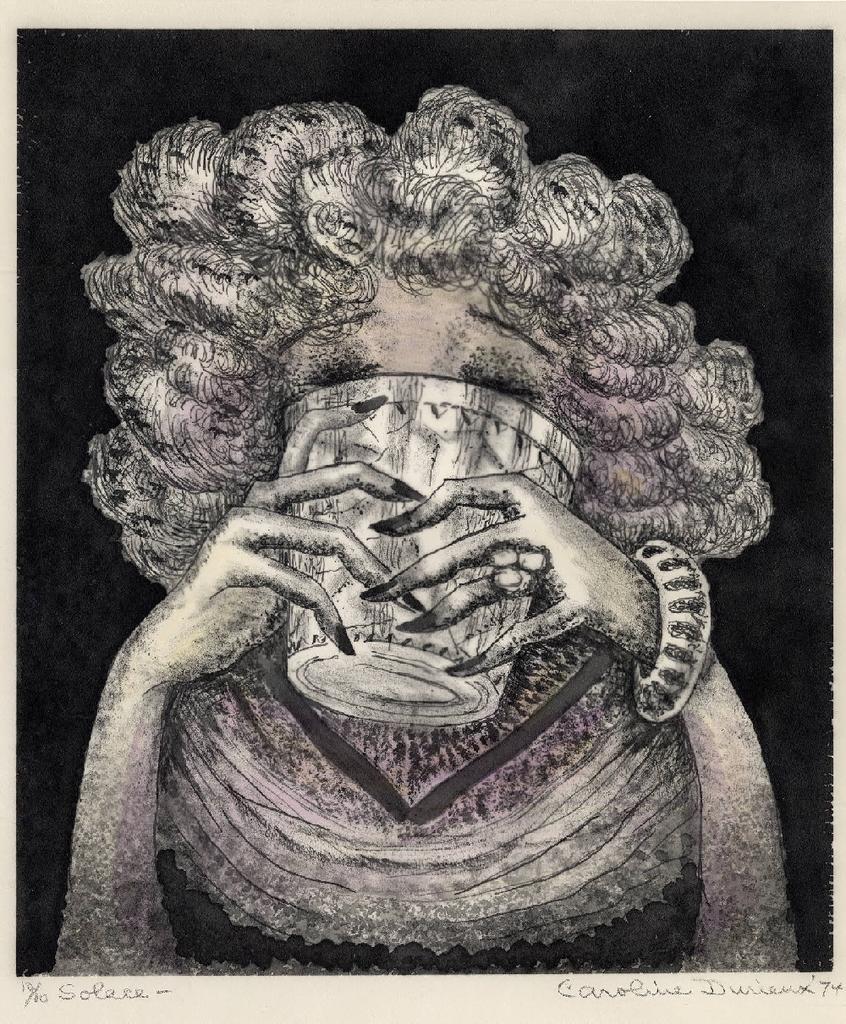How would you summarize this image in a sentence or two? In this image I can see depiction of a woman holding a glass. I can also see black colour in the background and on the bottom side of this image I can see something is written. 